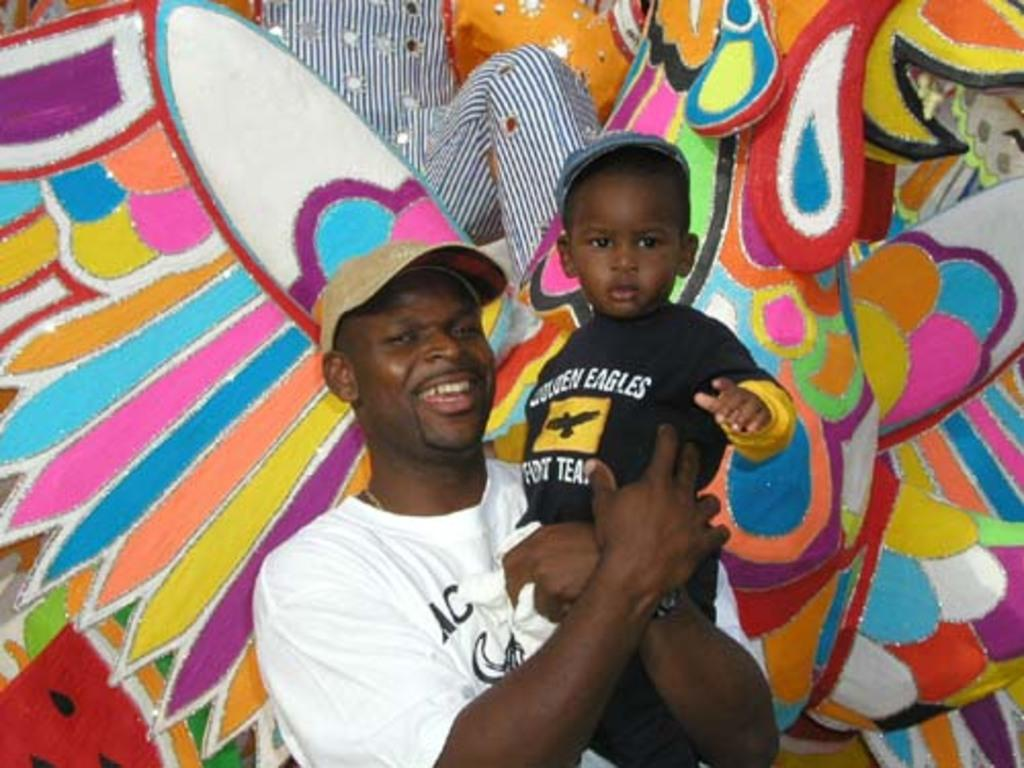Provide a one-sentence caption for the provided image. A father holds up his son who is wearing a black Eagles shirt. 